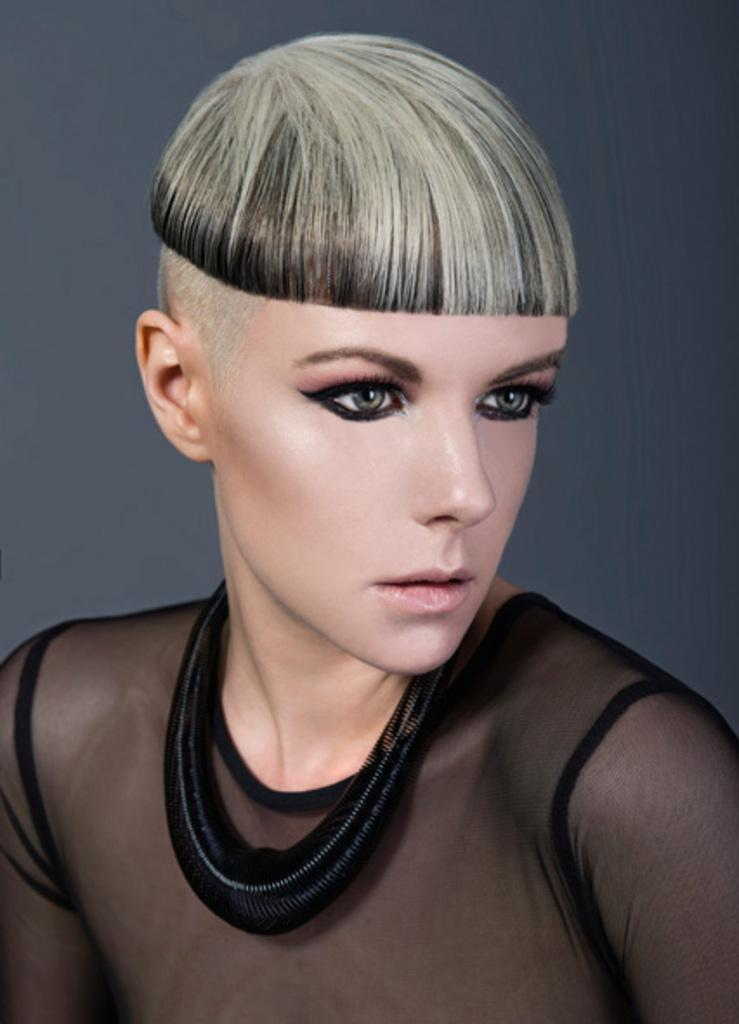Who is the main subject in the image? There is a woman in the image. Where is the woman located in the image? The woman is in the front of the image. What is the woman wearing in the image? The woman is wearing a black dress. What accessory is the woman wearing around her neck? There is a black object around the woman's neck. How many trees can be seen behind the woman in the image? There is no information about trees in the image, so we cannot determine how many trees are present. 